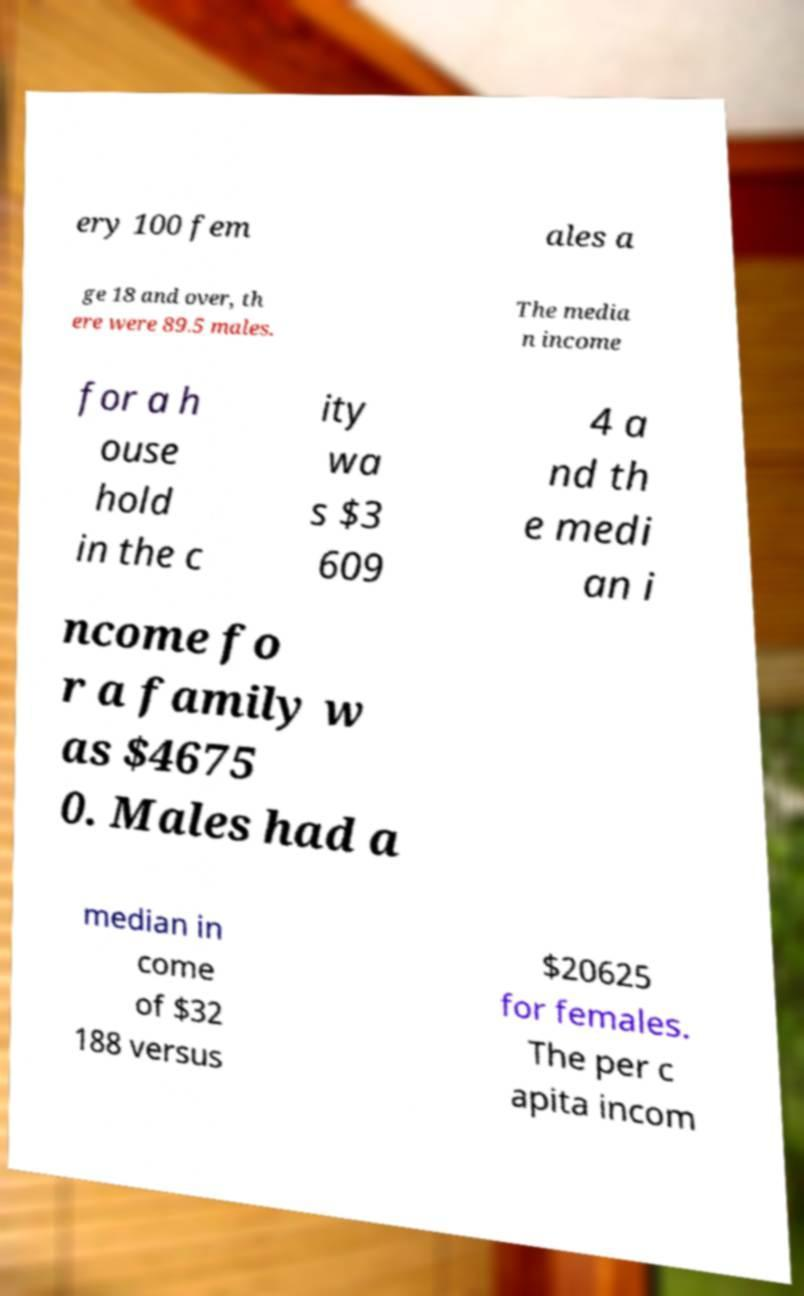Could you extract and type out the text from this image? ery 100 fem ales a ge 18 and over, th ere were 89.5 males. The media n income for a h ouse hold in the c ity wa s $3 609 4 a nd th e medi an i ncome fo r a family w as $4675 0. Males had a median in come of $32 188 versus $20625 for females. The per c apita incom 